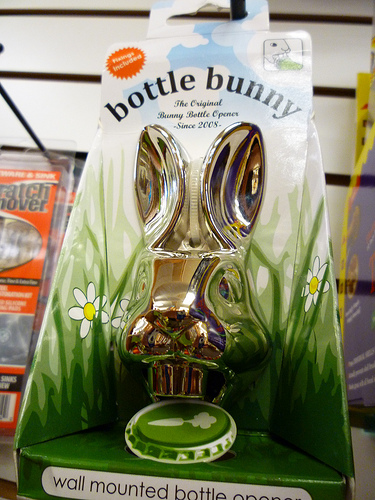<image>
Can you confirm if the bunny is to the right of the package? No. The bunny is not to the right of the package. The horizontal positioning shows a different relationship. 